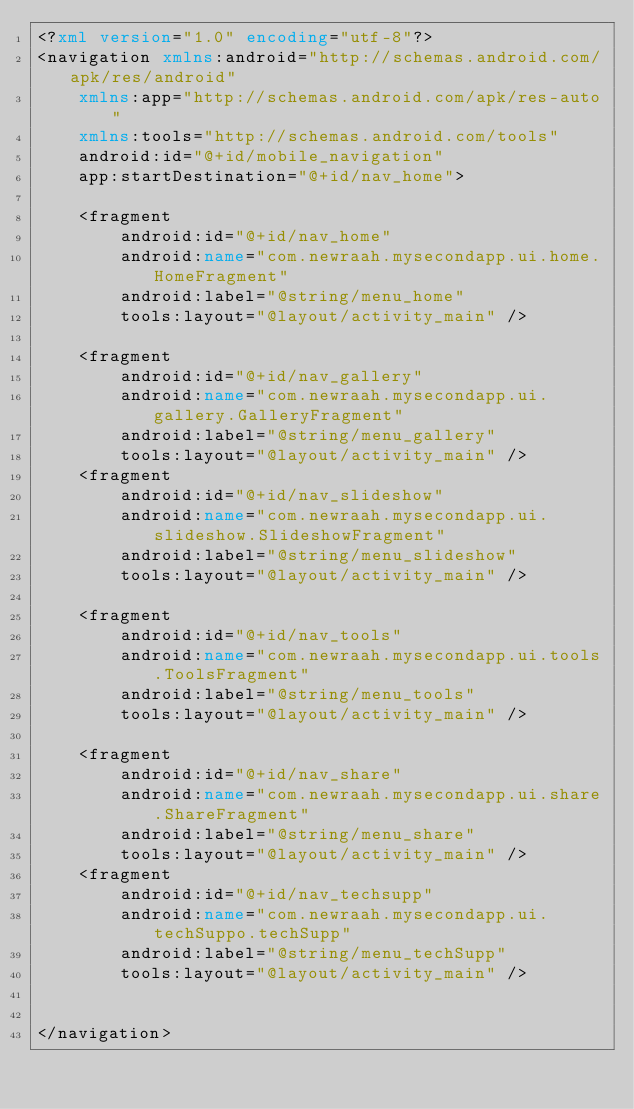Convert code to text. <code><loc_0><loc_0><loc_500><loc_500><_XML_><?xml version="1.0" encoding="utf-8"?>
<navigation xmlns:android="http://schemas.android.com/apk/res/android"
    xmlns:app="http://schemas.android.com/apk/res-auto"
    xmlns:tools="http://schemas.android.com/tools"
    android:id="@+id/mobile_navigation"
    app:startDestination="@+id/nav_home">

    <fragment
        android:id="@+id/nav_home"
        android:name="com.newraah.mysecondapp.ui.home.HomeFragment"
        android:label="@string/menu_home"
        tools:layout="@layout/activity_main" />

    <fragment
        android:id="@+id/nav_gallery"
        android:name="com.newraah.mysecondapp.ui.gallery.GalleryFragment"
        android:label="@string/menu_gallery"
        tools:layout="@layout/activity_main" />
    <fragment
        android:id="@+id/nav_slideshow"
        android:name="com.newraah.mysecondapp.ui.slideshow.SlideshowFragment"
        android:label="@string/menu_slideshow"
        tools:layout="@layout/activity_main" />

    <fragment
        android:id="@+id/nav_tools"
        android:name="com.newraah.mysecondapp.ui.tools.ToolsFragment"
        android:label="@string/menu_tools"
        tools:layout="@layout/activity_main" />

    <fragment
        android:id="@+id/nav_share"
        android:name="com.newraah.mysecondapp.ui.share.ShareFragment"
        android:label="@string/menu_share"
        tools:layout="@layout/activity_main" />
    <fragment
        android:id="@+id/nav_techsupp"
        android:name="com.newraah.mysecondapp.ui.techSuppo.techSupp"
        android:label="@string/menu_techSupp"
        tools:layout="@layout/activity_main" />


</navigation></code> 